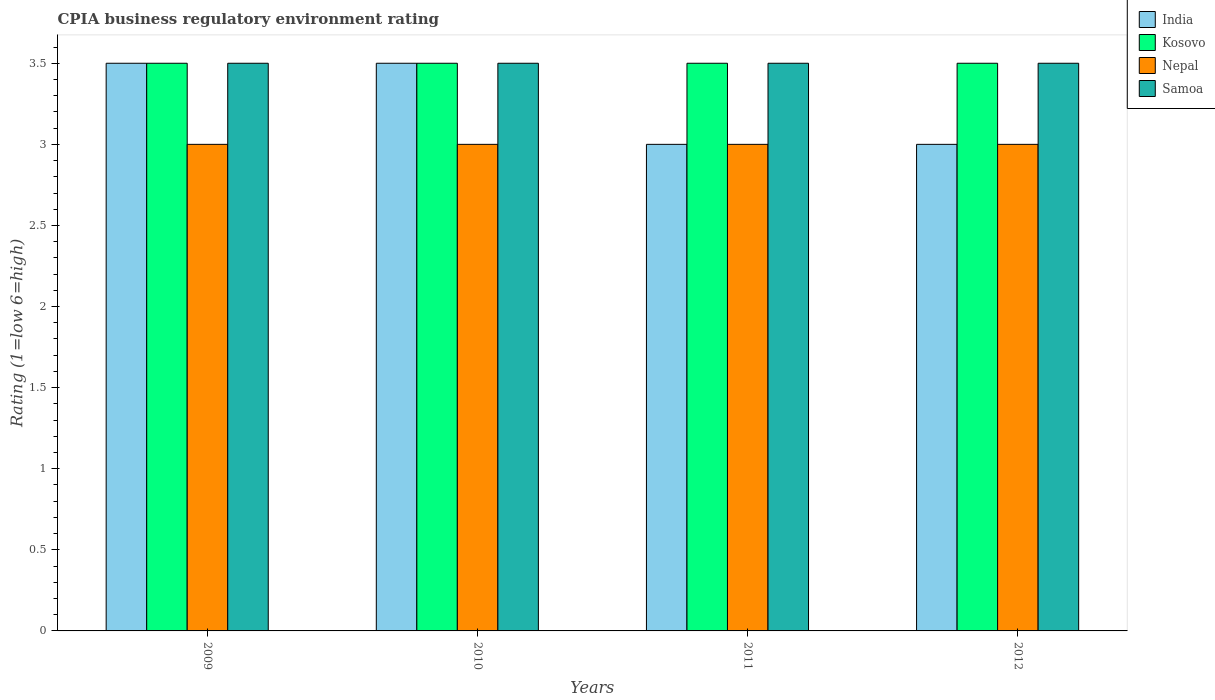How many different coloured bars are there?
Offer a very short reply. 4. How many groups of bars are there?
Your answer should be compact. 4. Are the number of bars on each tick of the X-axis equal?
Offer a very short reply. Yes. What is the label of the 3rd group of bars from the left?
Your response must be concise. 2011. In which year was the CPIA rating in India minimum?
Keep it short and to the point. 2011. What is the difference between the CPIA rating in India in 2009 and that in 2010?
Your answer should be compact. 0. What is the average CPIA rating in Nepal per year?
Keep it short and to the point. 3. In the year 2010, what is the difference between the CPIA rating in Samoa and CPIA rating in India?
Keep it short and to the point. 0. What is the ratio of the CPIA rating in India in 2010 to that in 2011?
Provide a succinct answer. 1.17. Is the CPIA rating in Nepal in 2009 less than that in 2012?
Offer a terse response. No. Is the difference between the CPIA rating in Samoa in 2009 and 2012 greater than the difference between the CPIA rating in India in 2009 and 2012?
Your response must be concise. No. What is the difference between the highest and the second highest CPIA rating in India?
Offer a terse response. 0. In how many years, is the CPIA rating in India greater than the average CPIA rating in India taken over all years?
Give a very brief answer. 2. What does the 3rd bar from the left in 2012 represents?
Offer a very short reply. Nepal. What does the 2nd bar from the right in 2010 represents?
Offer a terse response. Nepal. How many bars are there?
Your answer should be very brief. 16. Are all the bars in the graph horizontal?
Keep it short and to the point. No. Does the graph contain any zero values?
Ensure brevity in your answer.  No. Does the graph contain grids?
Your response must be concise. No. Where does the legend appear in the graph?
Ensure brevity in your answer.  Top right. How many legend labels are there?
Offer a very short reply. 4. How are the legend labels stacked?
Your response must be concise. Vertical. What is the title of the graph?
Your answer should be very brief. CPIA business regulatory environment rating. What is the label or title of the X-axis?
Provide a short and direct response. Years. What is the Rating (1=low 6=high) of India in 2009?
Your response must be concise. 3.5. What is the Rating (1=low 6=high) in Kosovo in 2009?
Give a very brief answer. 3.5. What is the Rating (1=low 6=high) of Nepal in 2009?
Ensure brevity in your answer.  3. What is the Rating (1=low 6=high) of Kosovo in 2010?
Give a very brief answer. 3.5. What is the Rating (1=low 6=high) in Samoa in 2010?
Your response must be concise. 3.5. What is the Rating (1=low 6=high) in India in 2011?
Ensure brevity in your answer.  3. What is the Rating (1=low 6=high) in Samoa in 2011?
Keep it short and to the point. 3.5. What is the Rating (1=low 6=high) in Kosovo in 2012?
Provide a short and direct response. 3.5. What is the Rating (1=low 6=high) in Nepal in 2012?
Make the answer very short. 3. Across all years, what is the maximum Rating (1=low 6=high) in Kosovo?
Your answer should be compact. 3.5. Across all years, what is the minimum Rating (1=low 6=high) in India?
Your answer should be very brief. 3. Across all years, what is the minimum Rating (1=low 6=high) of Kosovo?
Your answer should be very brief. 3.5. Across all years, what is the minimum Rating (1=low 6=high) of Nepal?
Provide a short and direct response. 3. Across all years, what is the minimum Rating (1=low 6=high) of Samoa?
Your answer should be compact. 3.5. What is the total Rating (1=low 6=high) in Kosovo in the graph?
Provide a short and direct response. 14. What is the difference between the Rating (1=low 6=high) in India in 2009 and that in 2010?
Your response must be concise. 0. What is the difference between the Rating (1=low 6=high) in Kosovo in 2009 and that in 2010?
Offer a terse response. 0. What is the difference between the Rating (1=low 6=high) of Samoa in 2009 and that in 2010?
Ensure brevity in your answer.  0. What is the difference between the Rating (1=low 6=high) in India in 2009 and that in 2011?
Provide a short and direct response. 0.5. What is the difference between the Rating (1=low 6=high) of Nepal in 2009 and that in 2011?
Provide a short and direct response. 0. What is the difference between the Rating (1=low 6=high) in Samoa in 2009 and that in 2011?
Offer a very short reply. 0. What is the difference between the Rating (1=low 6=high) in India in 2009 and that in 2012?
Keep it short and to the point. 0.5. What is the difference between the Rating (1=low 6=high) of Kosovo in 2009 and that in 2012?
Give a very brief answer. 0. What is the difference between the Rating (1=low 6=high) of Nepal in 2009 and that in 2012?
Give a very brief answer. 0. What is the difference between the Rating (1=low 6=high) of Samoa in 2009 and that in 2012?
Your response must be concise. 0. What is the difference between the Rating (1=low 6=high) in Kosovo in 2010 and that in 2011?
Give a very brief answer. 0. What is the difference between the Rating (1=low 6=high) of Nepal in 2010 and that in 2011?
Provide a succinct answer. 0. What is the difference between the Rating (1=low 6=high) in India in 2010 and that in 2012?
Offer a very short reply. 0.5. What is the difference between the Rating (1=low 6=high) of Samoa in 2010 and that in 2012?
Keep it short and to the point. 0. What is the difference between the Rating (1=low 6=high) in Kosovo in 2011 and that in 2012?
Your answer should be compact. 0. What is the difference between the Rating (1=low 6=high) in Nepal in 2009 and the Rating (1=low 6=high) in Samoa in 2010?
Offer a terse response. -0.5. What is the difference between the Rating (1=low 6=high) of India in 2009 and the Rating (1=low 6=high) of Samoa in 2011?
Ensure brevity in your answer.  0. What is the difference between the Rating (1=low 6=high) of Nepal in 2009 and the Rating (1=low 6=high) of Samoa in 2011?
Your answer should be very brief. -0.5. What is the difference between the Rating (1=low 6=high) of India in 2009 and the Rating (1=low 6=high) of Nepal in 2012?
Your response must be concise. 0.5. What is the difference between the Rating (1=low 6=high) in Kosovo in 2009 and the Rating (1=low 6=high) in Samoa in 2012?
Offer a terse response. 0. What is the difference between the Rating (1=low 6=high) of India in 2010 and the Rating (1=low 6=high) of Kosovo in 2011?
Ensure brevity in your answer.  0. What is the difference between the Rating (1=low 6=high) of India in 2010 and the Rating (1=low 6=high) of Samoa in 2011?
Your response must be concise. 0. What is the difference between the Rating (1=low 6=high) in Kosovo in 2010 and the Rating (1=low 6=high) in Nepal in 2011?
Offer a terse response. 0.5. What is the difference between the Rating (1=low 6=high) in Kosovo in 2010 and the Rating (1=low 6=high) in Samoa in 2011?
Your answer should be compact. 0. What is the difference between the Rating (1=low 6=high) in Nepal in 2010 and the Rating (1=low 6=high) in Samoa in 2011?
Provide a succinct answer. -0.5. What is the difference between the Rating (1=low 6=high) in India in 2010 and the Rating (1=low 6=high) in Samoa in 2012?
Your response must be concise. 0. What is the difference between the Rating (1=low 6=high) in Kosovo in 2010 and the Rating (1=low 6=high) in Samoa in 2012?
Give a very brief answer. 0. What is the difference between the Rating (1=low 6=high) in India in 2011 and the Rating (1=low 6=high) in Samoa in 2012?
Give a very brief answer. -0.5. What is the difference between the Rating (1=low 6=high) of Kosovo in 2011 and the Rating (1=low 6=high) of Nepal in 2012?
Offer a very short reply. 0.5. What is the difference between the Rating (1=low 6=high) of Nepal in 2011 and the Rating (1=low 6=high) of Samoa in 2012?
Provide a succinct answer. -0.5. What is the average Rating (1=low 6=high) of Kosovo per year?
Provide a succinct answer. 3.5. What is the average Rating (1=low 6=high) of Nepal per year?
Make the answer very short. 3. What is the average Rating (1=low 6=high) in Samoa per year?
Your answer should be compact. 3.5. In the year 2009, what is the difference between the Rating (1=low 6=high) of India and Rating (1=low 6=high) of Kosovo?
Your answer should be very brief. 0. In the year 2010, what is the difference between the Rating (1=low 6=high) of Kosovo and Rating (1=low 6=high) of Nepal?
Make the answer very short. 0.5. In the year 2010, what is the difference between the Rating (1=low 6=high) in Kosovo and Rating (1=low 6=high) in Samoa?
Provide a succinct answer. 0. In the year 2011, what is the difference between the Rating (1=low 6=high) of India and Rating (1=low 6=high) of Kosovo?
Offer a very short reply. -0.5. In the year 2011, what is the difference between the Rating (1=low 6=high) of Kosovo and Rating (1=low 6=high) of Nepal?
Keep it short and to the point. 0.5. In the year 2011, what is the difference between the Rating (1=low 6=high) in Kosovo and Rating (1=low 6=high) in Samoa?
Your answer should be compact. 0. In the year 2012, what is the difference between the Rating (1=low 6=high) of India and Rating (1=low 6=high) of Nepal?
Your answer should be very brief. 0. In the year 2012, what is the difference between the Rating (1=low 6=high) of Kosovo and Rating (1=low 6=high) of Nepal?
Provide a short and direct response. 0.5. In the year 2012, what is the difference between the Rating (1=low 6=high) of Kosovo and Rating (1=low 6=high) of Samoa?
Your answer should be compact. 0. In the year 2012, what is the difference between the Rating (1=low 6=high) in Nepal and Rating (1=low 6=high) in Samoa?
Provide a succinct answer. -0.5. What is the ratio of the Rating (1=low 6=high) of Nepal in 2009 to that in 2010?
Ensure brevity in your answer.  1. What is the ratio of the Rating (1=low 6=high) of Samoa in 2009 to that in 2010?
Provide a succinct answer. 1. What is the ratio of the Rating (1=low 6=high) in Kosovo in 2009 to that in 2011?
Offer a terse response. 1. What is the ratio of the Rating (1=low 6=high) in Nepal in 2009 to that in 2011?
Keep it short and to the point. 1. What is the ratio of the Rating (1=low 6=high) in Samoa in 2009 to that in 2012?
Make the answer very short. 1. What is the ratio of the Rating (1=low 6=high) of Kosovo in 2010 to that in 2011?
Your answer should be very brief. 1. What is the ratio of the Rating (1=low 6=high) of Samoa in 2010 to that in 2011?
Your answer should be compact. 1. What is the ratio of the Rating (1=low 6=high) in Kosovo in 2011 to that in 2012?
Ensure brevity in your answer.  1. What is the ratio of the Rating (1=low 6=high) in Samoa in 2011 to that in 2012?
Your response must be concise. 1. What is the difference between the highest and the second highest Rating (1=low 6=high) of Kosovo?
Offer a terse response. 0. What is the difference between the highest and the second highest Rating (1=low 6=high) of Samoa?
Make the answer very short. 0. What is the difference between the highest and the lowest Rating (1=low 6=high) in Nepal?
Provide a succinct answer. 0. What is the difference between the highest and the lowest Rating (1=low 6=high) of Samoa?
Give a very brief answer. 0. 